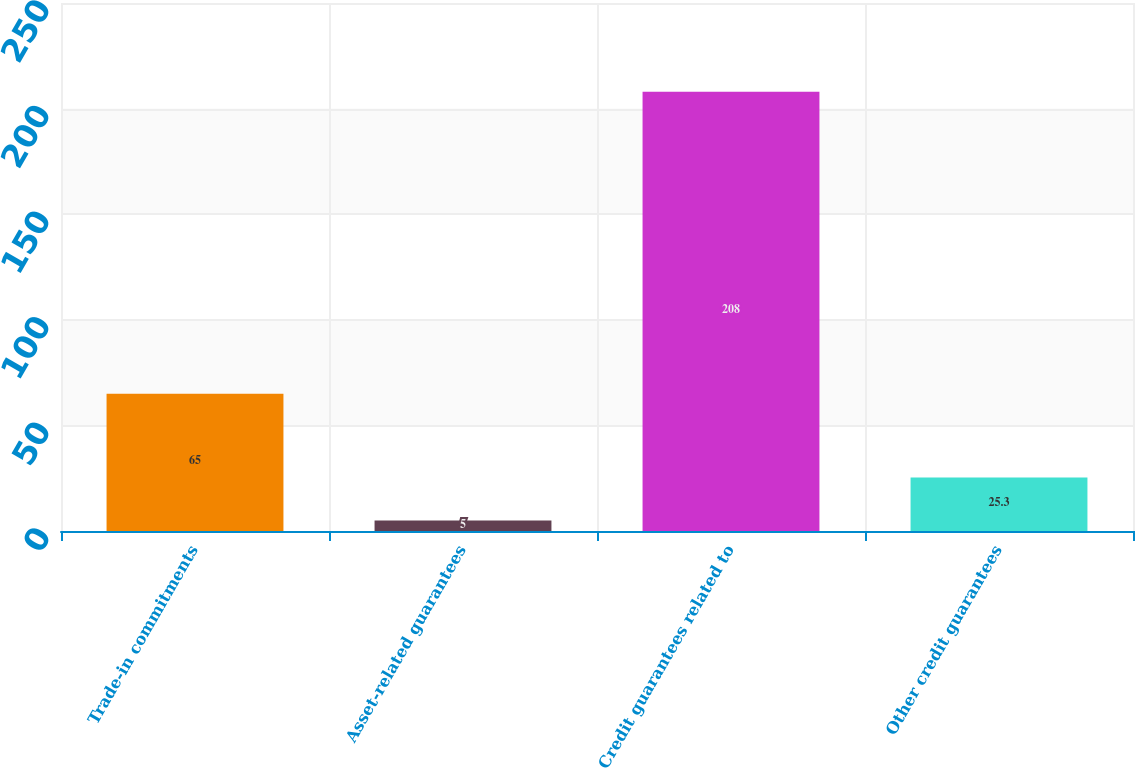Convert chart. <chart><loc_0><loc_0><loc_500><loc_500><bar_chart><fcel>Trade-in commitments<fcel>Asset-related guarantees<fcel>Credit guarantees related to<fcel>Other credit guarantees<nl><fcel>65<fcel>5<fcel>208<fcel>25.3<nl></chart> 